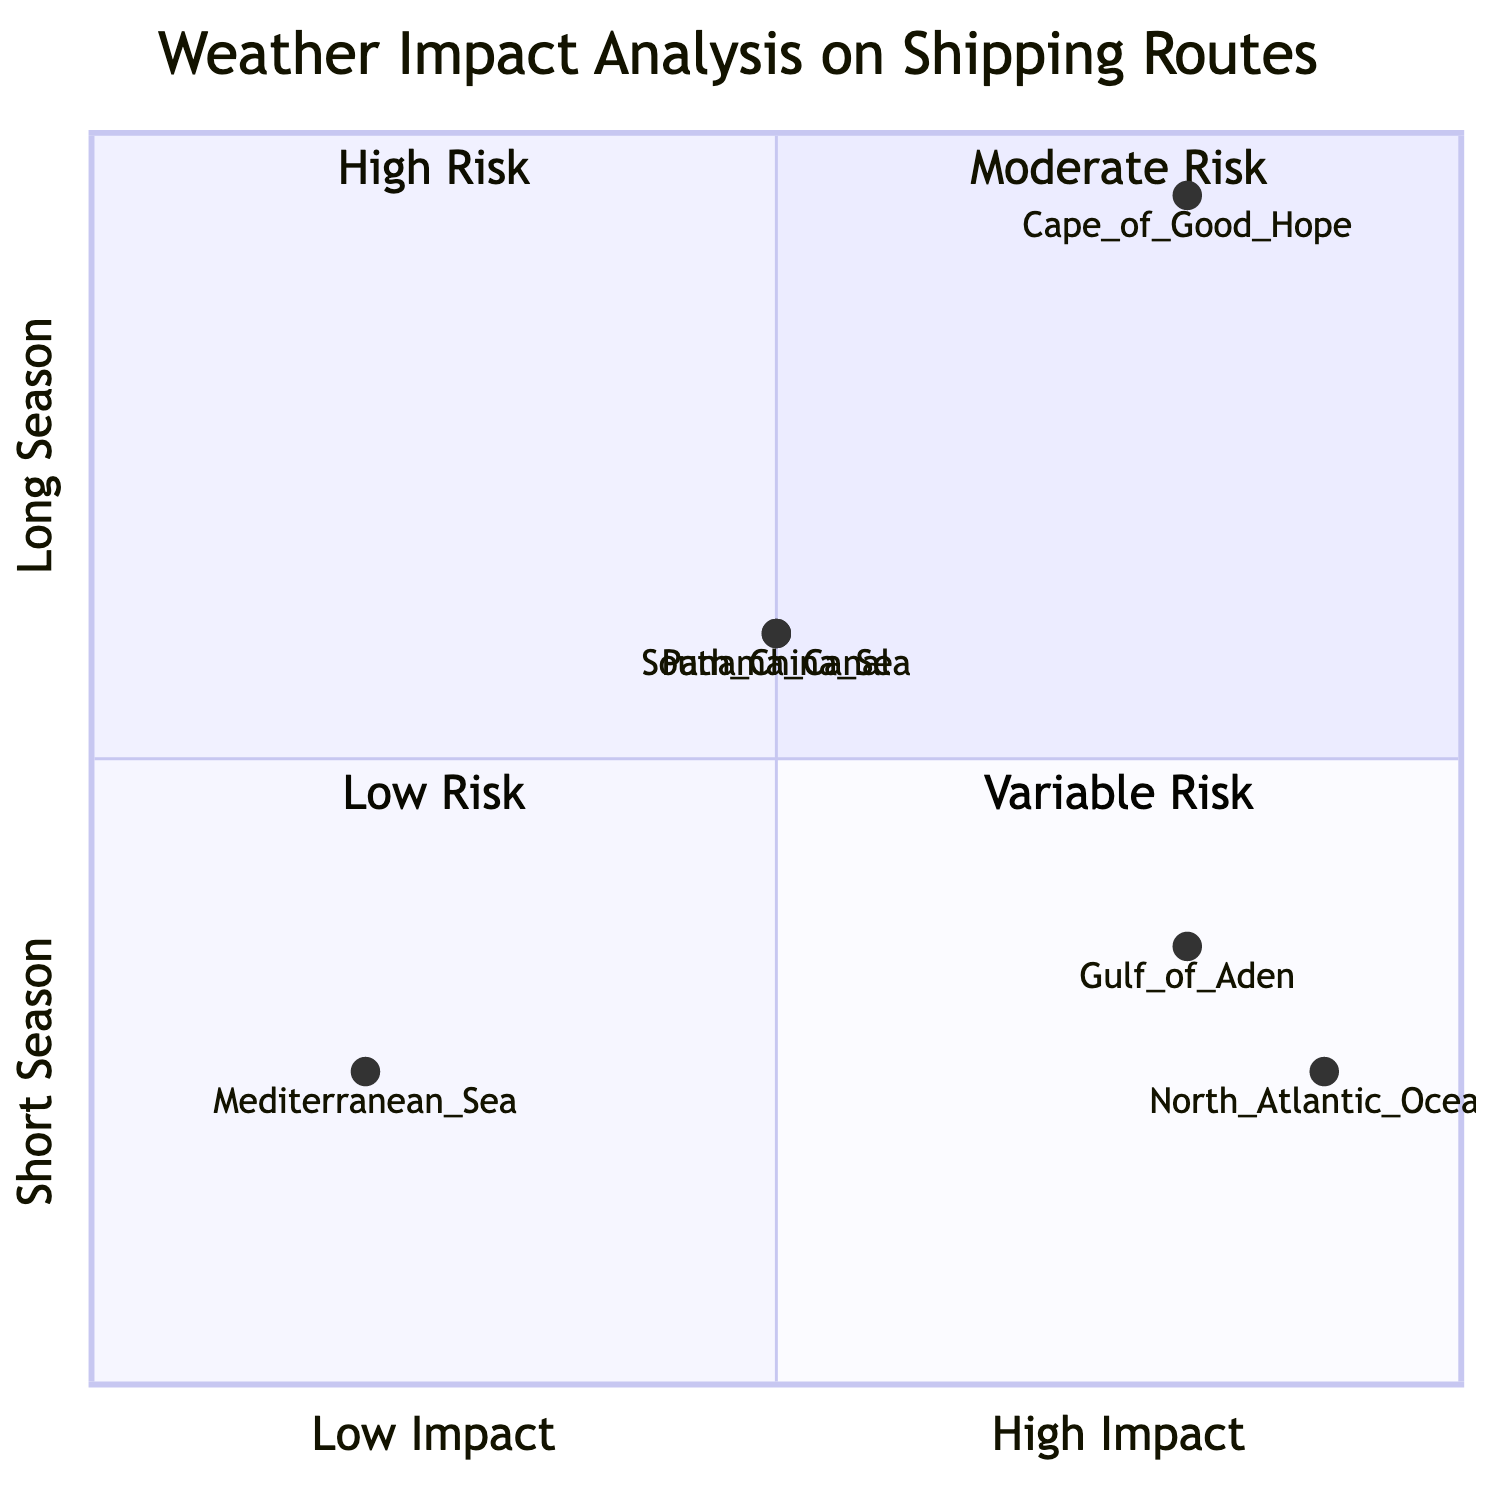What is the risk level of the Mediterranean Sea? The Mediterranean Sea is located in quadrant-1 of the diagram, which represents Moderate Risk.
Answer: Moderate Risk Which region has the highest weather impact? The Gulf of Aden is located in quadrant-2, indicating High Risk, which is the highest among the listed regions.
Answer: High Risk How many regions fall under Low Risk? The diagram shows only one region in quadrant-3, which is Low Risk, namely the Mediterranean Sea.
Answer: 1 Which two regions share the same weather risk classification? Both the South China Sea and Panama Canal are in quadrant-2, categorized as High Risk.
Answer: South China Sea and Panama Canal What is the x-axis value for the Cape of Good Hope? The Cape of Good Hope is noted at (0.8, 0.95), and the x-axis value is 0.8.
Answer: 0.8 How does the risk of the North Atlantic Ocean compare to the Gulf of Aden? The North Atlantic Ocean is in quadrant-4 (Variable Risk) and the Gulf of Aden is in quadrant-2 (High Risk); thus, the Gulf of Aden has a higher risk classification.
Answer: Gulf of Aden has higher risk In which quadrant does the Cape of Good Hope lie? The Cape of Good Hope is located in quadrant-4 of the diagram, denoting Variable Risk.
Answer: Quadrant 4 What are the coordinates of the South China Sea? The South China Sea is represented by the coordinates (0.5, 0.6).
Answer: (0.5, 0.6) Which region has a longer weather season, the Gulf of Aden or the Mediterranean Sea? The Gulf of Aden has a y-axis value of 0.35, which is higher than the Mediterranean Sea's value of 0.25, indicating a longer season.
Answer: Gulf of Aden 